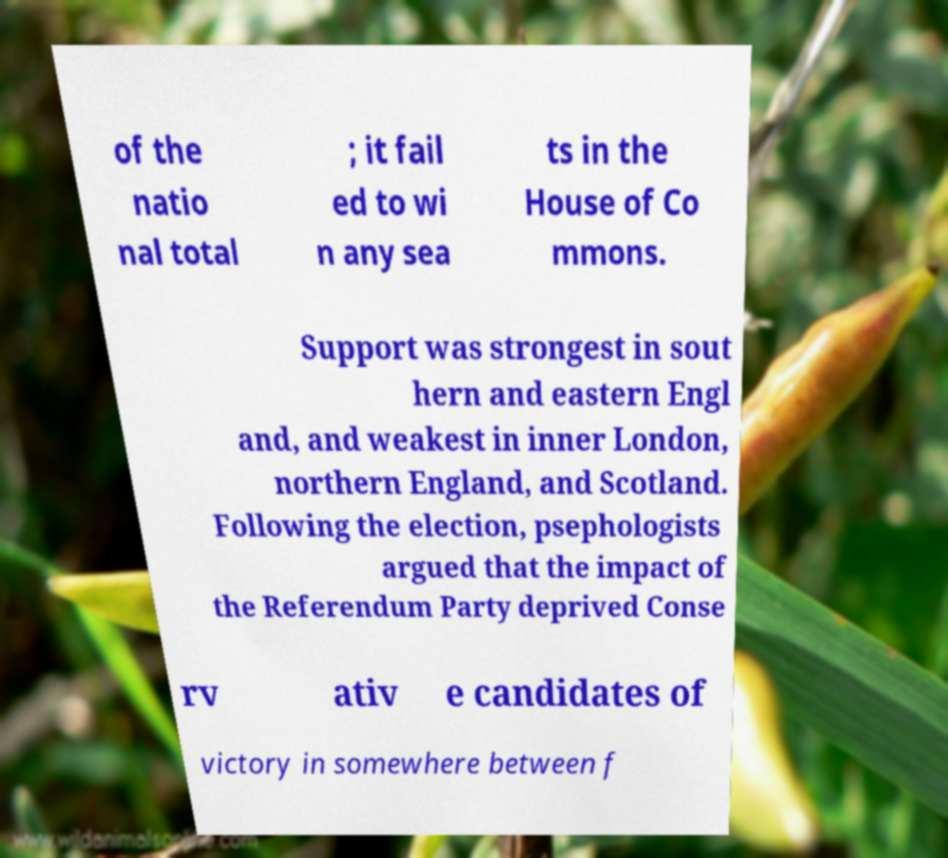Could you assist in decoding the text presented in this image and type it out clearly? of the natio nal total ; it fail ed to wi n any sea ts in the House of Co mmons. Support was strongest in sout hern and eastern Engl and, and weakest in inner London, northern England, and Scotland. Following the election, psephologists argued that the impact of the Referendum Party deprived Conse rv ativ e candidates of victory in somewhere between f 